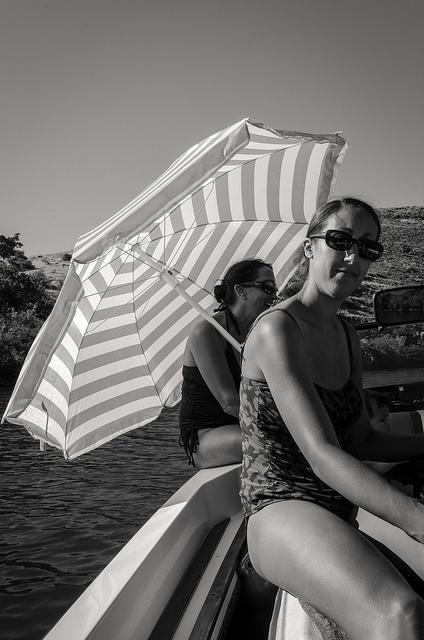How do the woman's eyewear help her health?
Answer briefly. Protection from sun rays. What are the women wearing?
Keep it brief. Swimsuits. Which woman is closer?
Give a very brief answer. Without umbrella. 